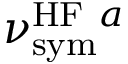<formula> <loc_0><loc_0><loc_500><loc_500>\nu _ { s y m } ^ { H F a }</formula> 